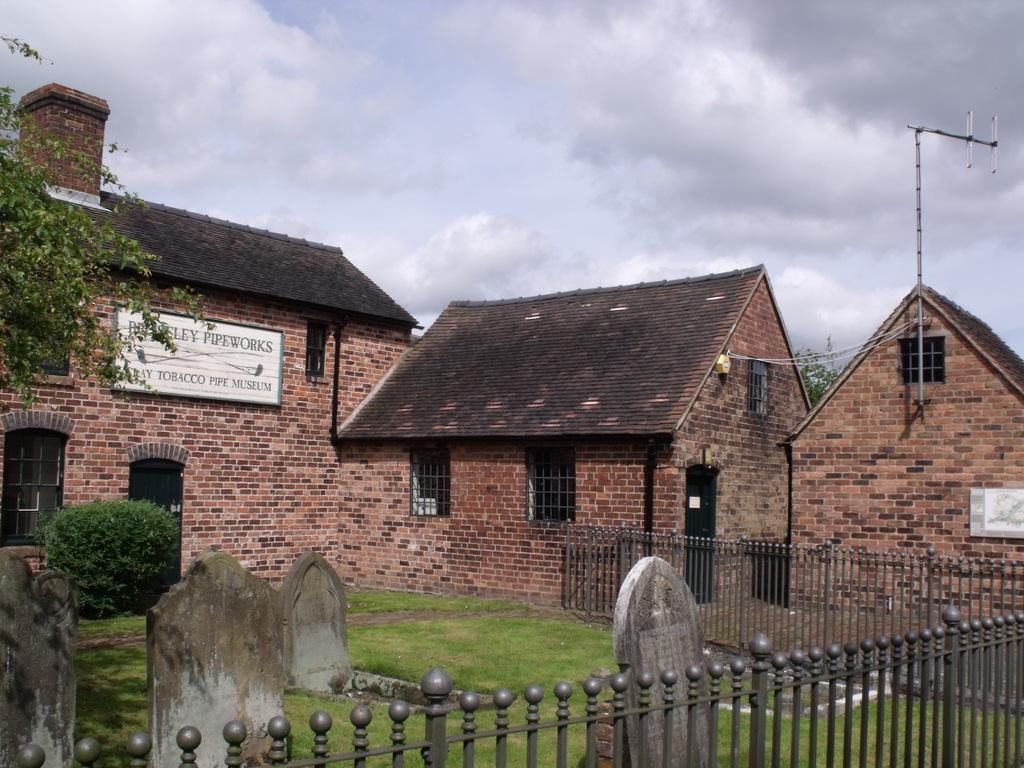What type of barrier can be seen in the image? There is a fence in the image. What type of vegetation is present in the image? There is grass, a tree, and a plant in the image. What type of structure is present in the image? There is a current pole in the image. What type of signage is present in the image? There is a banner in the image. What type of residential structures are present in the image? There are houses in the image. What architectural feature can be seen in the houses? There are windows in the houses. What type of cemetery is present in the image? There are graveyards in the image. What is visible at the top of the image? The sky is visible at the top of the image. What type of weather can be inferred from the sky? There are clouds in the sky, suggesting partly cloudy weather. What arithmetic problem is being solved on the banner in the image? There is no arithmetic problem present on the banner in the image. What type of boats can be seen in the graveyard in the image? There are no boats present in the image, let alone in the graveyard. 